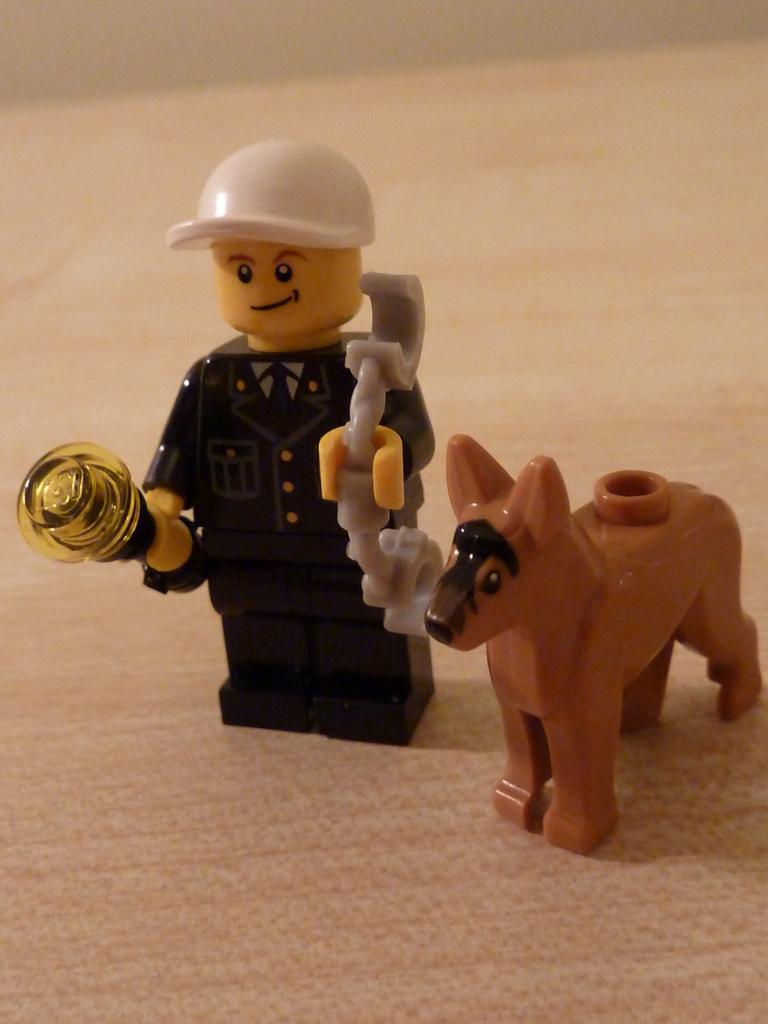What objects can be seen on the surface in the image? There are toys on a surface in the image. Can you see any cherries on the toys in the image? There are no cherries present in the image; it features toys on a surface. What type of polish is being applied to the toys in the image? There is no polish being applied to the toys in the image; it simply shows toys on a surface. 